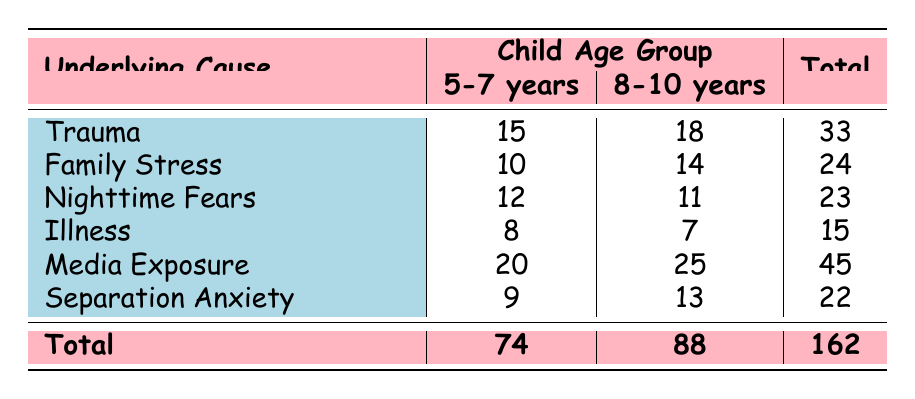What is the total number of children who experienced nightmares due to trauma? The table shows that for the age group 5-7 years, 15 children experienced nightmares due to trauma, and for the age group 8-10 years, 18 children experienced nightmares for the same reason. Adding these together, 15 + 18 = 33.
Answer: 33 How many children aged 5-7 years experienced nightmares due to media exposure? According to the table, 20 children aged 5-7 years experienced nightmares due to media exposure.
Answer: 20 Which age group had a higher total number of nightmares related to family stress? To find out which age group had a higher total for family stress, look at the two entries: 10 children for 5-7 years and 14 children for 8-10 years. Since 14 is greater than 10, the 8-10 years age group had a higher total.
Answer: 8-10 years What is the average number of children who experienced nightmares due to nighttime fears across both age groups? For nighttime fears, there are 12 children in the 5-7 years age group and 11 children in the 8-10 years age group. To find the average, sum the numbers: 12 + 11 = 23. Since there are 2 age groups, divide by 2: 23/2 = 11.5.
Answer: 11.5 Is it true that the frequency of nightmares due to illness is the same for both age groups? The table shows that 8 children in the 5-7 years age group experienced nightmares due to illness, and 7 children in the 8-10 years age group did. Since 8 is not equal to 7, it is false that the frequencies are the same.
Answer: No How many children in total experienced nightmares due to separation anxiety? Referring to the table, there are 9 children aged 5-7 years and 13 children aged 8-10 years who experienced nightmares due to separation anxiety. Adding these counts together gives: 9 + 13 = 22.
Answer: 22 Which underlying cause had the highest frequency of nightmares for children aged 8-10 years? According to the table, for the 8-10 years age group, the highest number is 25 children who experienced nightmares due to media exposure.
Answer: Media Exposure How many more children experienced nightmares due to media exposure compared to those who experienced them due to illness across both age groups? First, find the totals: media exposure has 20 (5-7 years) + 25 (8-10 years) = 45. Illness has 8 (5-7 years) + 7 (8-10 years) = 15. Now, calculate the difference: 45 - 15 = 30.
Answer: 30 What percentage of the total nightmares across both age groups was caused by nighttime fears? The total number of children who experienced nightmares is 162. The number who experienced nightmares due to nighttime fears, from both groups, is 23. To find the percentage, divide 23 by 162 and multiply by 100: (23/162) * 100 ≈ 14.2%.
Answer: 14.2% 